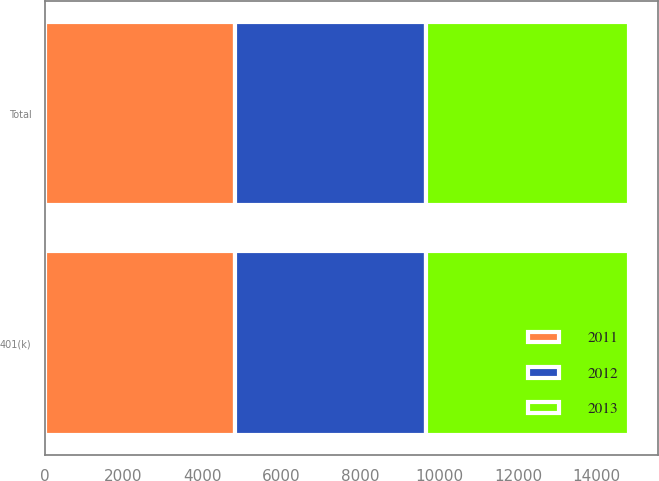<chart> <loc_0><loc_0><loc_500><loc_500><stacked_bar_chart><ecel><fcel>401(k)<fcel>Total<nl><fcel>2012<fcel>4865<fcel>4865<nl><fcel>2013<fcel>5138<fcel>5138<nl><fcel>2011<fcel>4813<fcel>4813<nl></chart> 